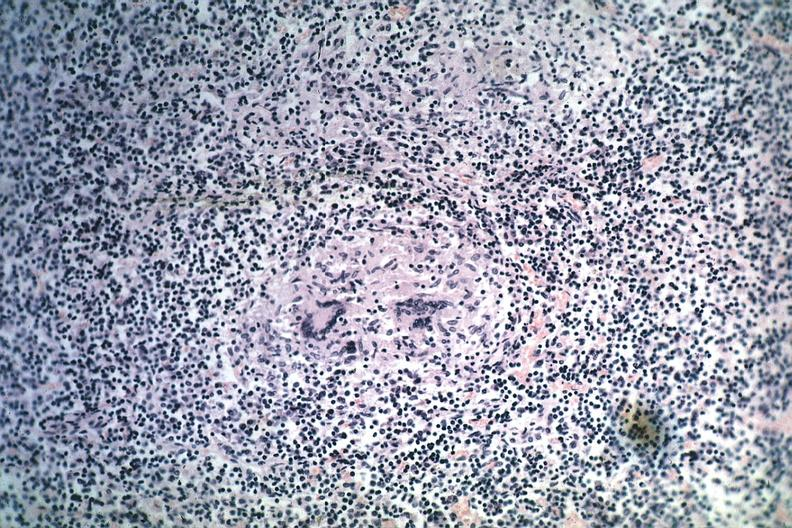does sella show granuloma with minimal necrosis source unknown?
Answer the question using a single word or phrase. No 